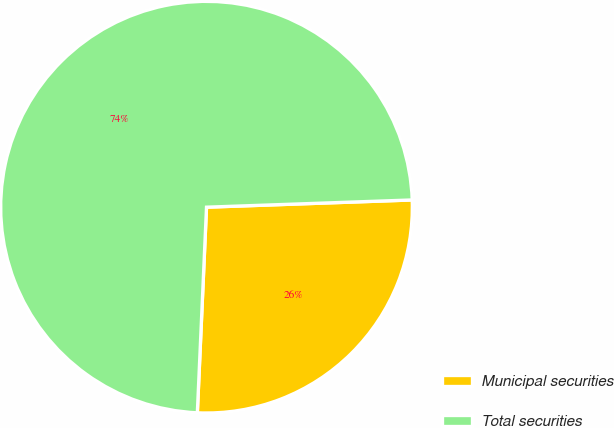<chart> <loc_0><loc_0><loc_500><loc_500><pie_chart><fcel>Municipal securities<fcel>Total securities<nl><fcel>26.27%<fcel>73.73%<nl></chart> 